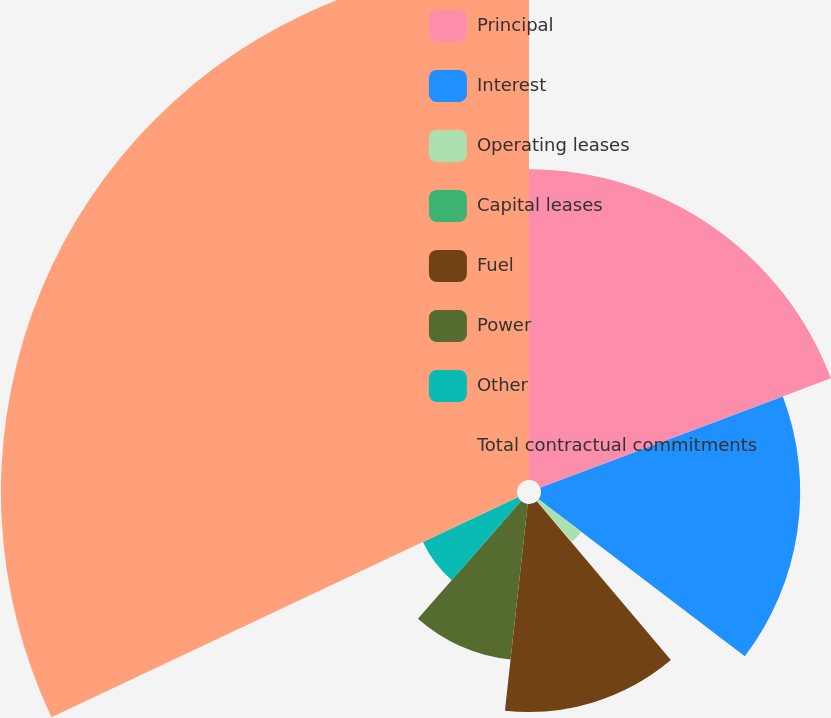<chart> <loc_0><loc_0><loc_500><loc_500><pie_chart><fcel>Principal<fcel>Interest<fcel>Operating leases<fcel>Capital leases<fcel>Fuel<fcel>Power<fcel>Other<fcel>Total contractual commitments<nl><fcel>19.27%<fcel>16.08%<fcel>3.34%<fcel>0.15%<fcel>12.9%<fcel>9.71%<fcel>6.53%<fcel>32.01%<nl></chart> 